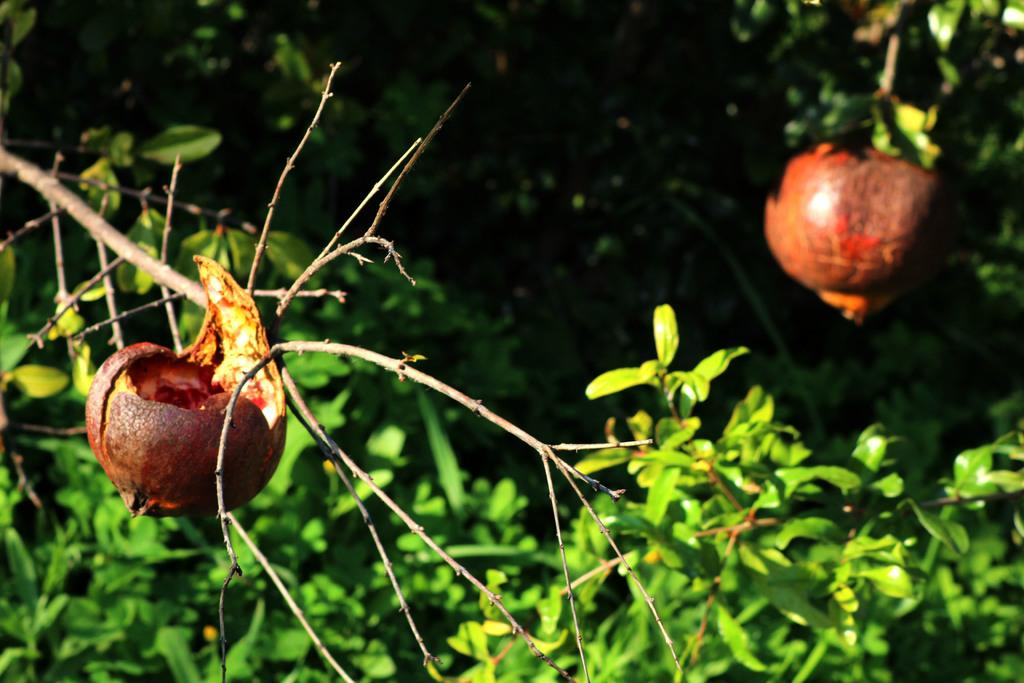What is the main object in the image? There is a tree in the image. What is the color of the tree? The tree is green in color. How many fruits are on the tree? There are two fruits on the tree. What are the colors of the fruits? One fruit is orange in color, and the other fruit is brown in color. What can be seen in the background of the image? The background of the image is black. What decision are the boys making in the image? There are no boys present in the image, and therefore no decision-making can be observed. How is the fruit distribution managed in the image? There is no fruit distribution being managed in the image; it simply shows a tree with two fruits. 